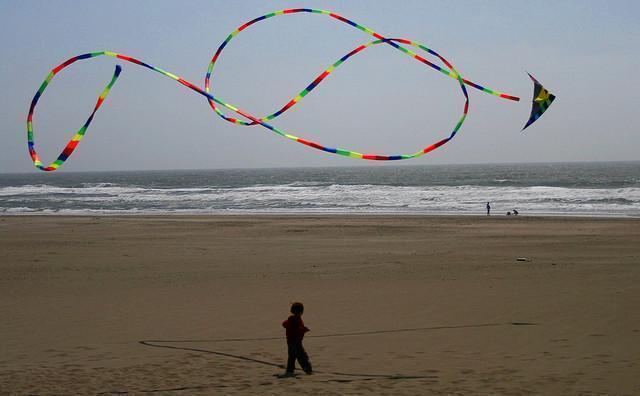What is unique about this kite?
Indicate the correct choice and explain in the format: 'Answer: answer
Rationale: rationale.'
Options: Tail, height, size, style. Answer: tail.
Rationale: A little boy is flying a kite on the beach. it has a really long tail that is multi colored. 